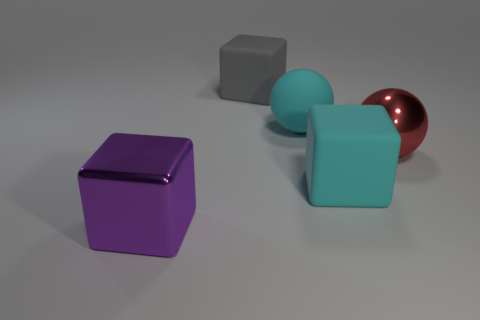Subtract all purple cubes. How many cubes are left? 2 Subtract all big metallic blocks. How many blocks are left? 2 Subtract 1 blocks. How many blocks are left? 2 Subtract all cubes. How many objects are left? 2 Add 4 brown metal blocks. How many objects exist? 9 Subtract all green cubes. How many brown balls are left? 0 Add 5 large rubber balls. How many large rubber balls are left? 6 Add 3 tiny cyan matte cylinders. How many tiny cyan matte cylinders exist? 3 Subtract 1 cyan balls. How many objects are left? 4 Subtract all red cubes. Subtract all purple spheres. How many cubes are left? 3 